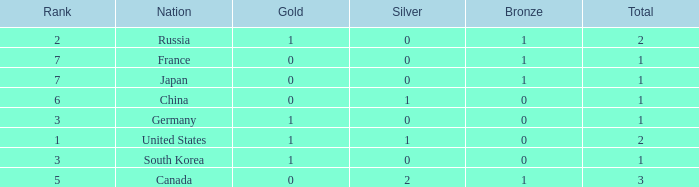Which Bronze has a Rank of 3, and a Silver larger than 0? None. 